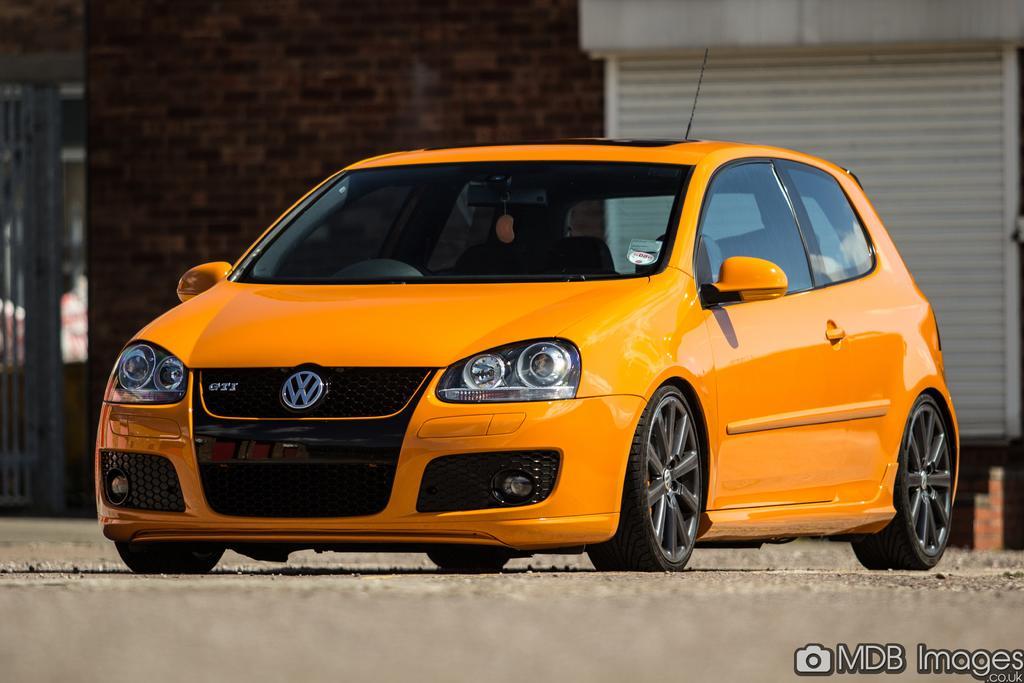Could you give a brief overview of what you see in this image? In this image we can see the orange color car on the road. In the background, we can see the wall. Here we can see the watermark on the bottom right side of the image. 